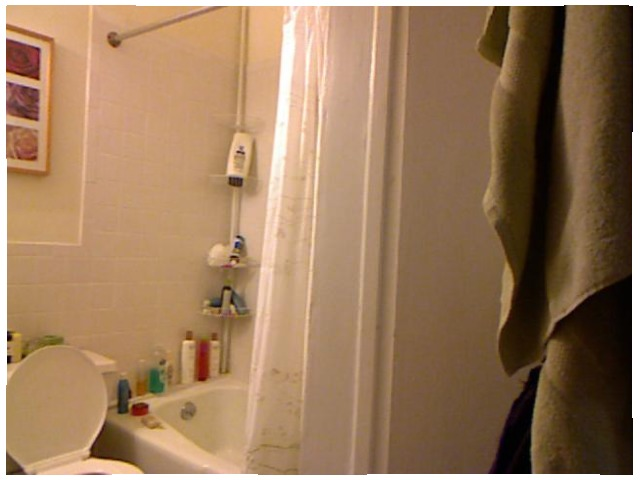<image>
Can you confirm if the shampoo is under the soap? No. The shampoo is not positioned under the soap. The vertical relationship between these objects is different. 